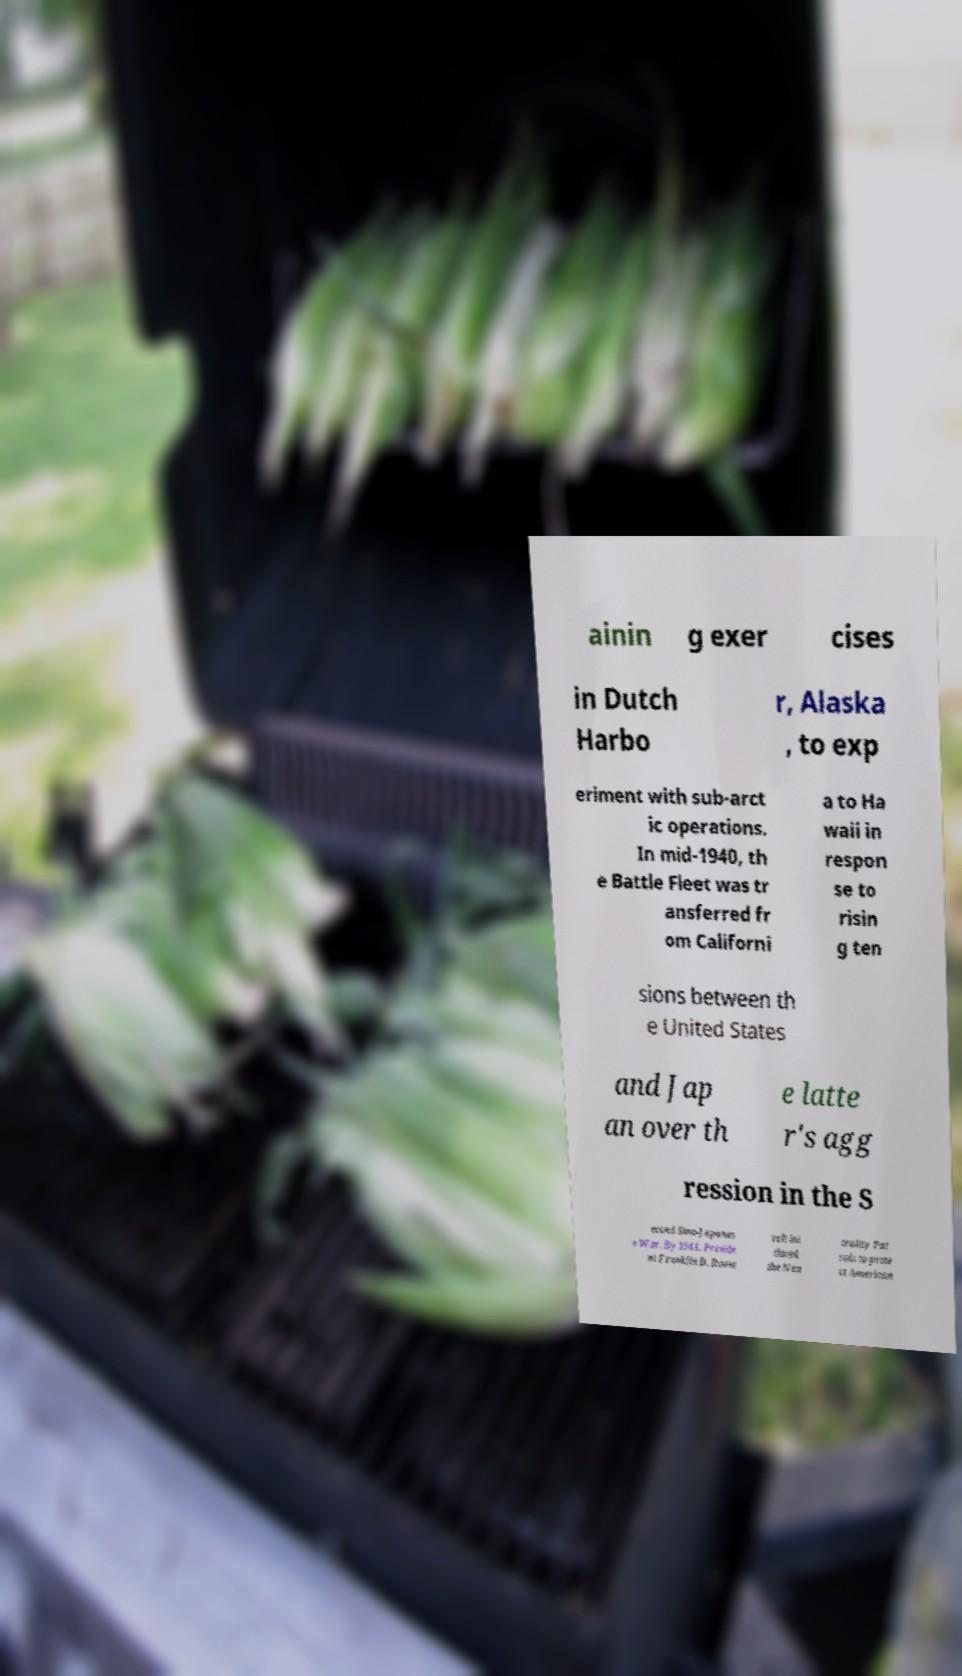For documentation purposes, I need the text within this image transcribed. Could you provide that? ainin g exer cises in Dutch Harbo r, Alaska , to exp eriment with sub-arct ic operations. In mid-1940, th e Battle Fleet was tr ansferred fr om Californi a to Ha waii in respon se to risin g ten sions between th e United States and Jap an over th e latte r's agg ression in the S econd Sino-Japanes e War. By 1941, Preside nt Franklin D. Roose velt ini tiated the Neu trality Pat rols to prote ct American 